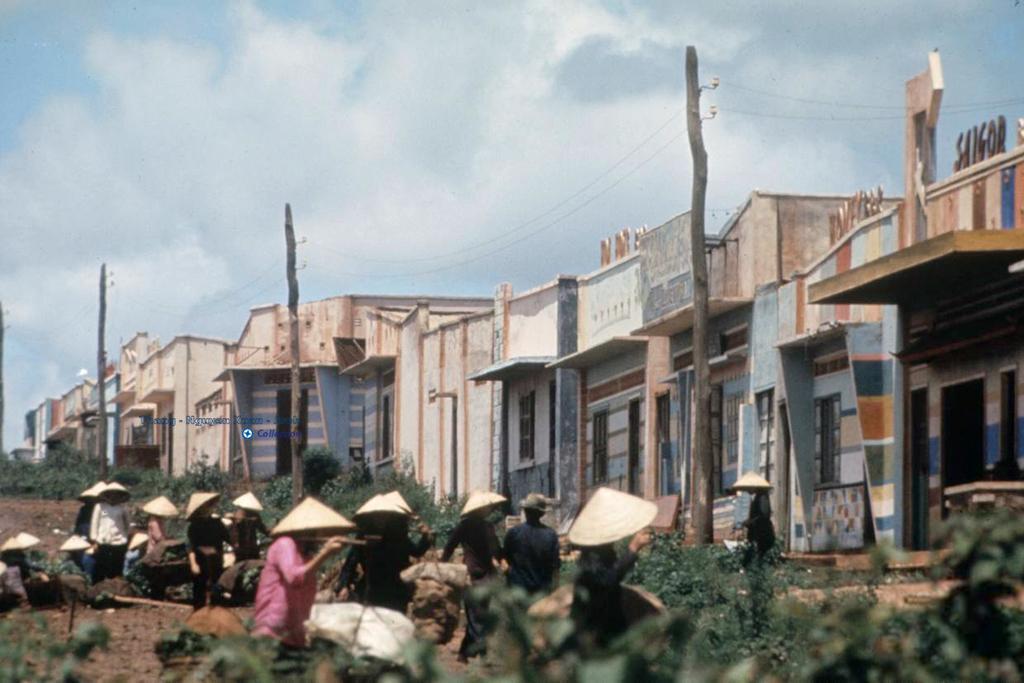In one or two sentences, can you explain what this image depicts? In this image I can see the group of people with different color dresses and the hats. To the side of these people I can see the plants. In-front of these people I can see the poles and the buildings. In the background I can see clouds and the sky. 